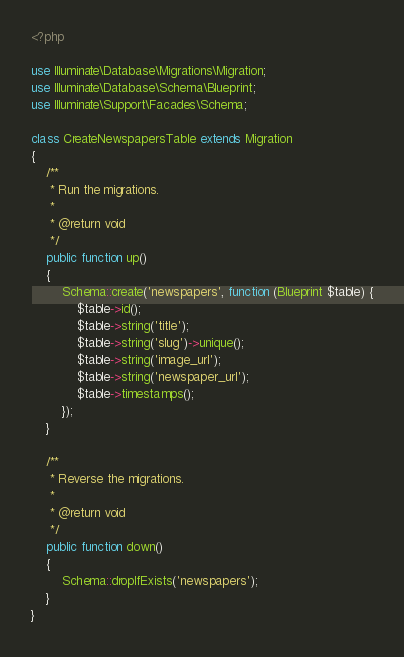Convert code to text. <code><loc_0><loc_0><loc_500><loc_500><_PHP_><?php

use Illuminate\Database\Migrations\Migration;
use Illuminate\Database\Schema\Blueprint;
use Illuminate\Support\Facades\Schema;

class CreateNewspapersTable extends Migration
{
    /**
     * Run the migrations.
     *
     * @return void
     */
    public function up()
    {
        Schema::create('newspapers', function (Blueprint $table) {
            $table->id();
            $table->string('title');
            $table->string('slug')->unique();
            $table->string('image_url');
            $table->string('newspaper_url');
            $table->timestamps();
        });
    }

    /**
     * Reverse the migrations.
     *
     * @return void
     */
    public function down()
    {
        Schema::dropIfExists('newspapers');
    }
}
</code> 